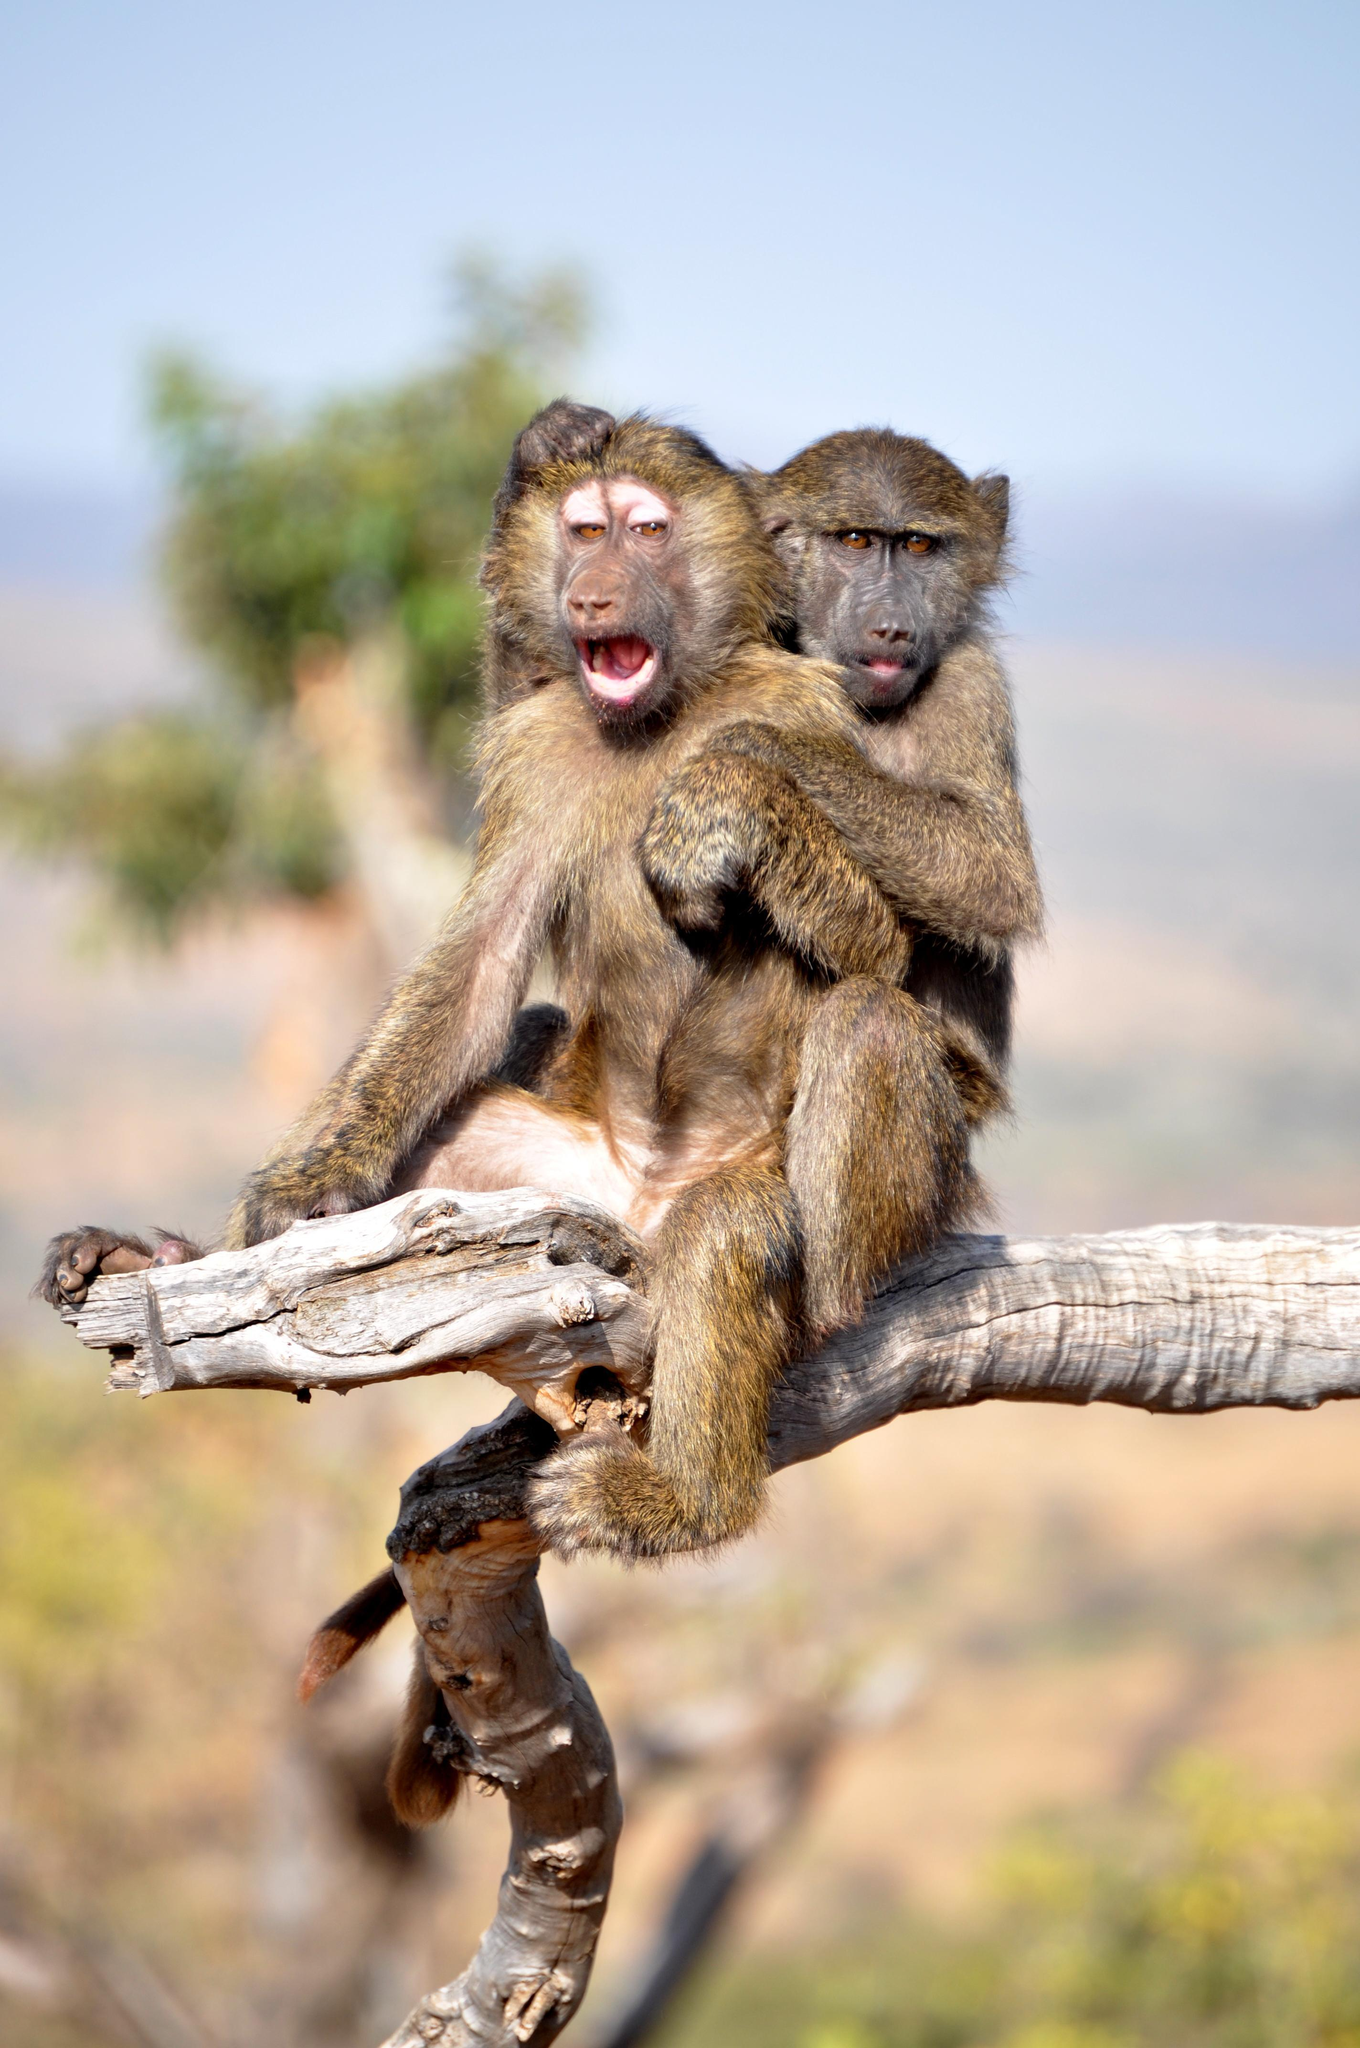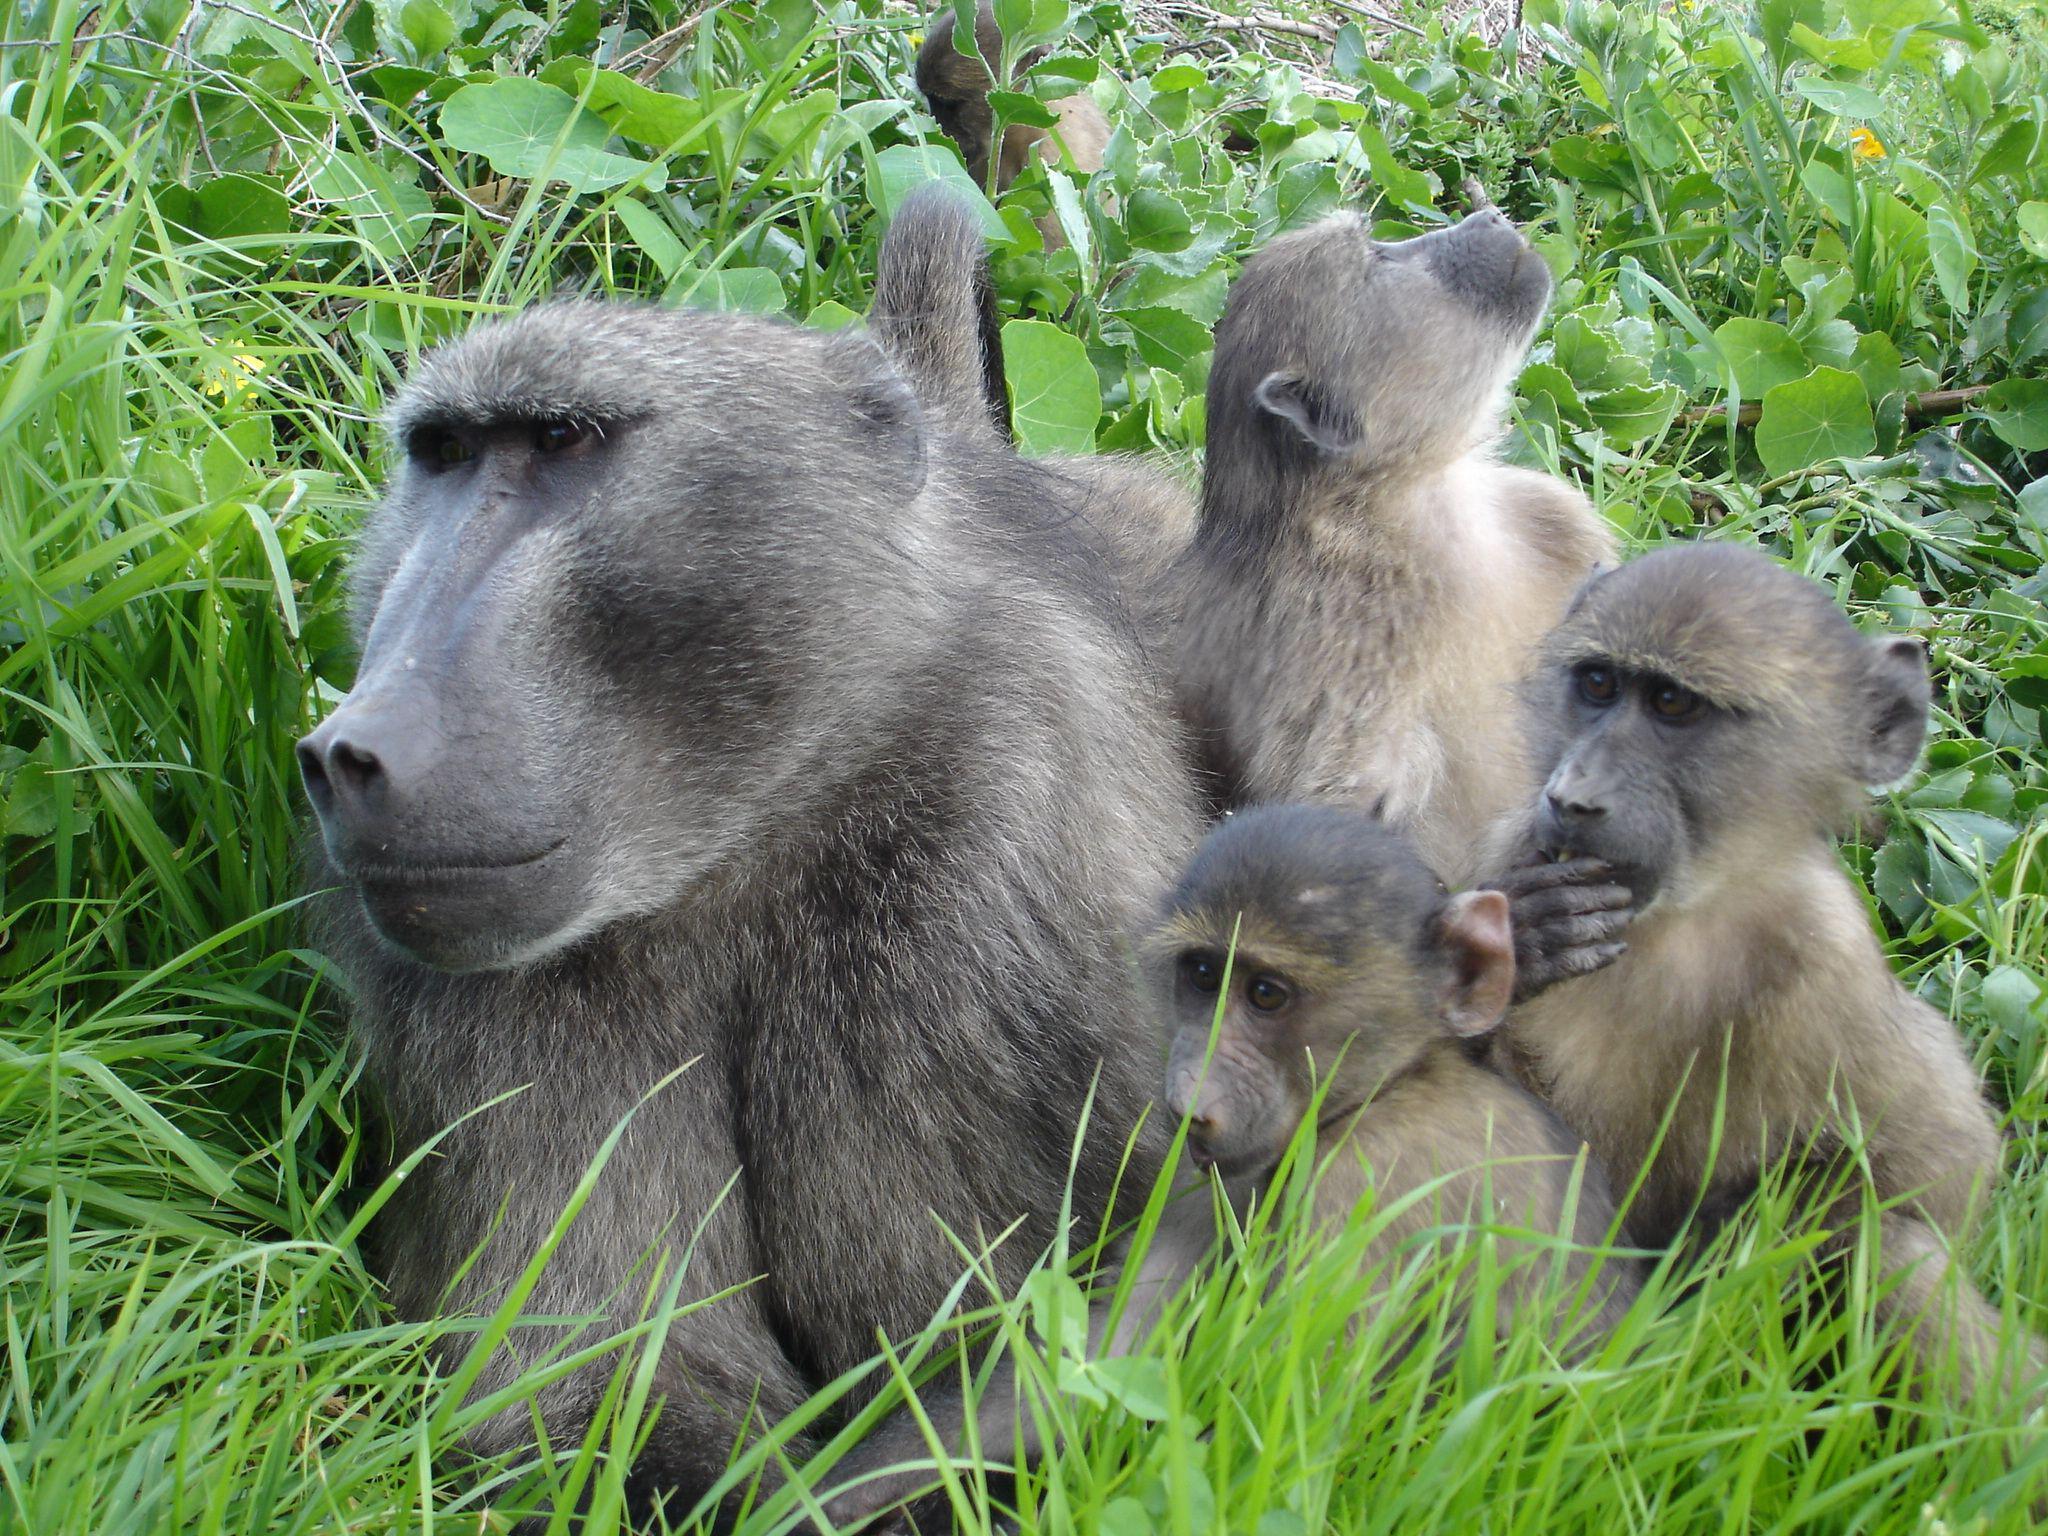The first image is the image on the left, the second image is the image on the right. For the images displayed, is the sentence "One monkey is holding onto another monkey from it's back in one of the images." factually correct? Answer yes or no. Yes. 